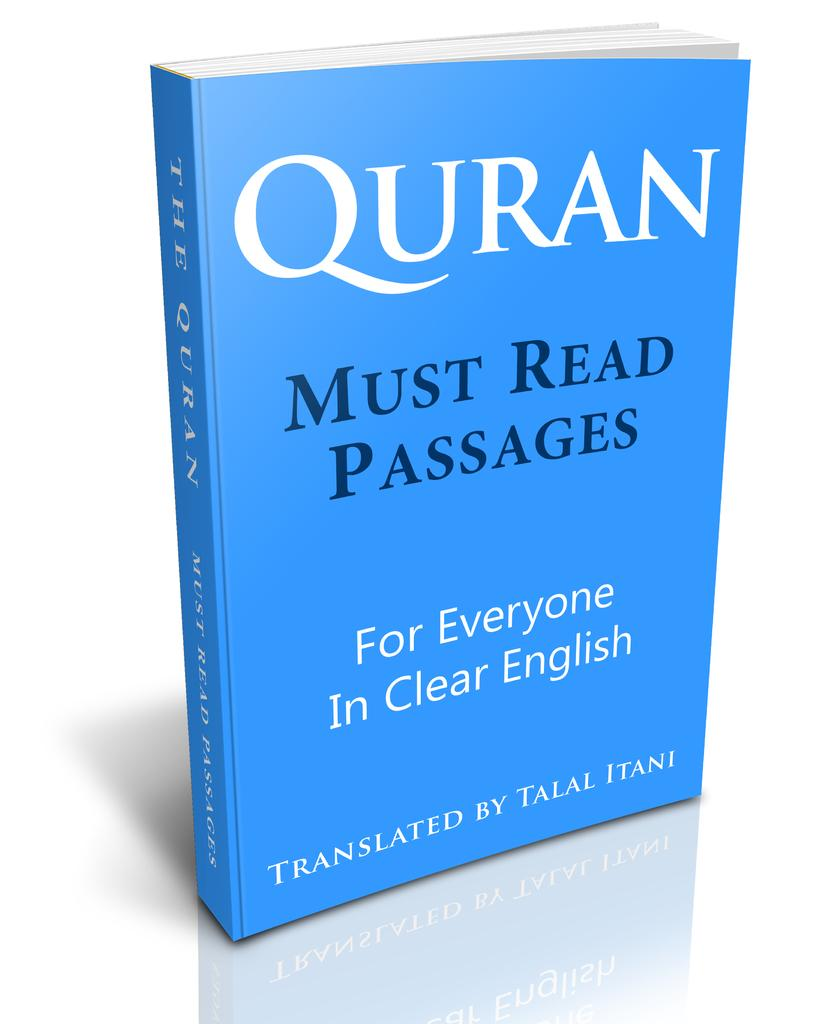<image>
Offer a succinct explanation of the picture presented. A blue Quran that focuses on Must Read Passages and is in English. 